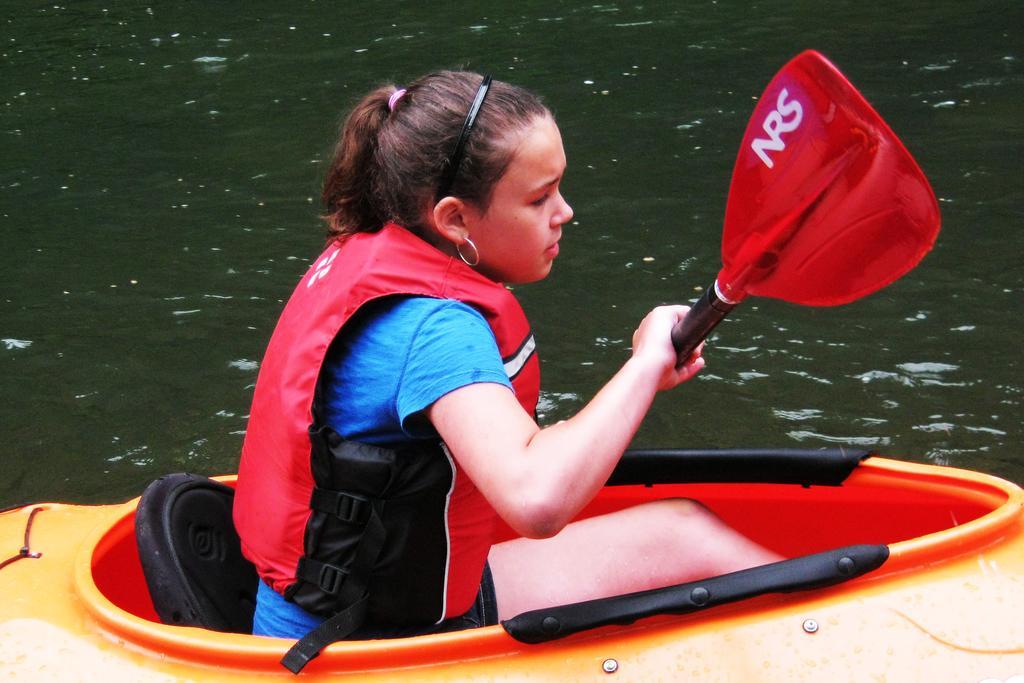How would you summarize this image in a sentence or two? In this image we can see a woman wearing life jacket holding stick with her hands is sitting in a boat placed on the water. 